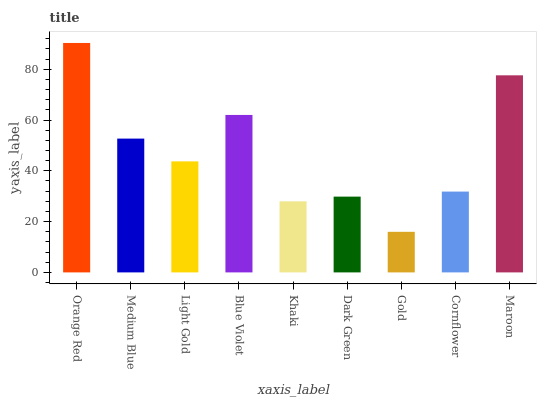Is Gold the minimum?
Answer yes or no. Yes. Is Orange Red the maximum?
Answer yes or no. Yes. Is Medium Blue the minimum?
Answer yes or no. No. Is Medium Blue the maximum?
Answer yes or no. No. Is Orange Red greater than Medium Blue?
Answer yes or no. Yes. Is Medium Blue less than Orange Red?
Answer yes or no. Yes. Is Medium Blue greater than Orange Red?
Answer yes or no. No. Is Orange Red less than Medium Blue?
Answer yes or no. No. Is Light Gold the high median?
Answer yes or no. Yes. Is Light Gold the low median?
Answer yes or no. Yes. Is Dark Green the high median?
Answer yes or no. No. Is Cornflower the low median?
Answer yes or no. No. 